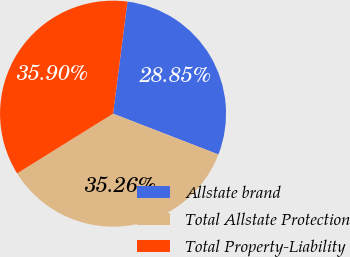Convert chart. <chart><loc_0><loc_0><loc_500><loc_500><pie_chart><fcel>Allstate brand<fcel>Total Allstate Protection<fcel>Total Property-Liability<nl><fcel>28.85%<fcel>35.26%<fcel>35.9%<nl></chart> 